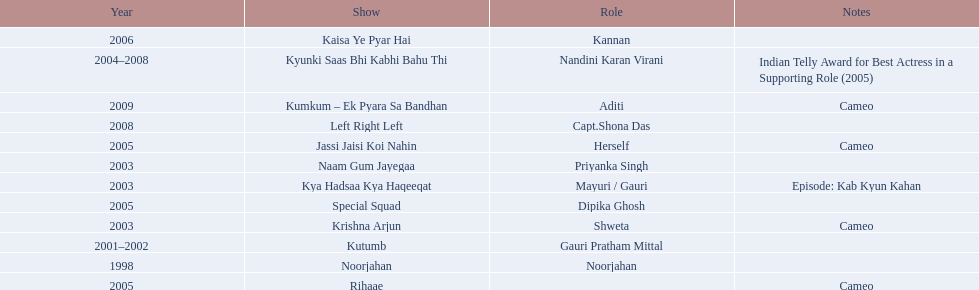What are all of the shows? Noorjahan, Kutumb, Krishna Arjun, Naam Gum Jayegaa, Kya Hadsaa Kya Haqeeqat, Kyunki Saas Bhi Kabhi Bahu Thi, Rihaae, Jassi Jaisi Koi Nahin, Special Squad, Kaisa Ye Pyar Hai, Left Right Left, Kumkum – Ek Pyara Sa Bandhan. When did they premiere? 1998, 2001–2002, 2003, 2003, 2003, 2004–2008, 2005, 2005, 2005, 2006, 2008, 2009. What notes are there for the shows from 2005? Cameo, Cameo. Along with rihaee, what is the other show gauri had a cameo role in? Jassi Jaisi Koi Nahin. 